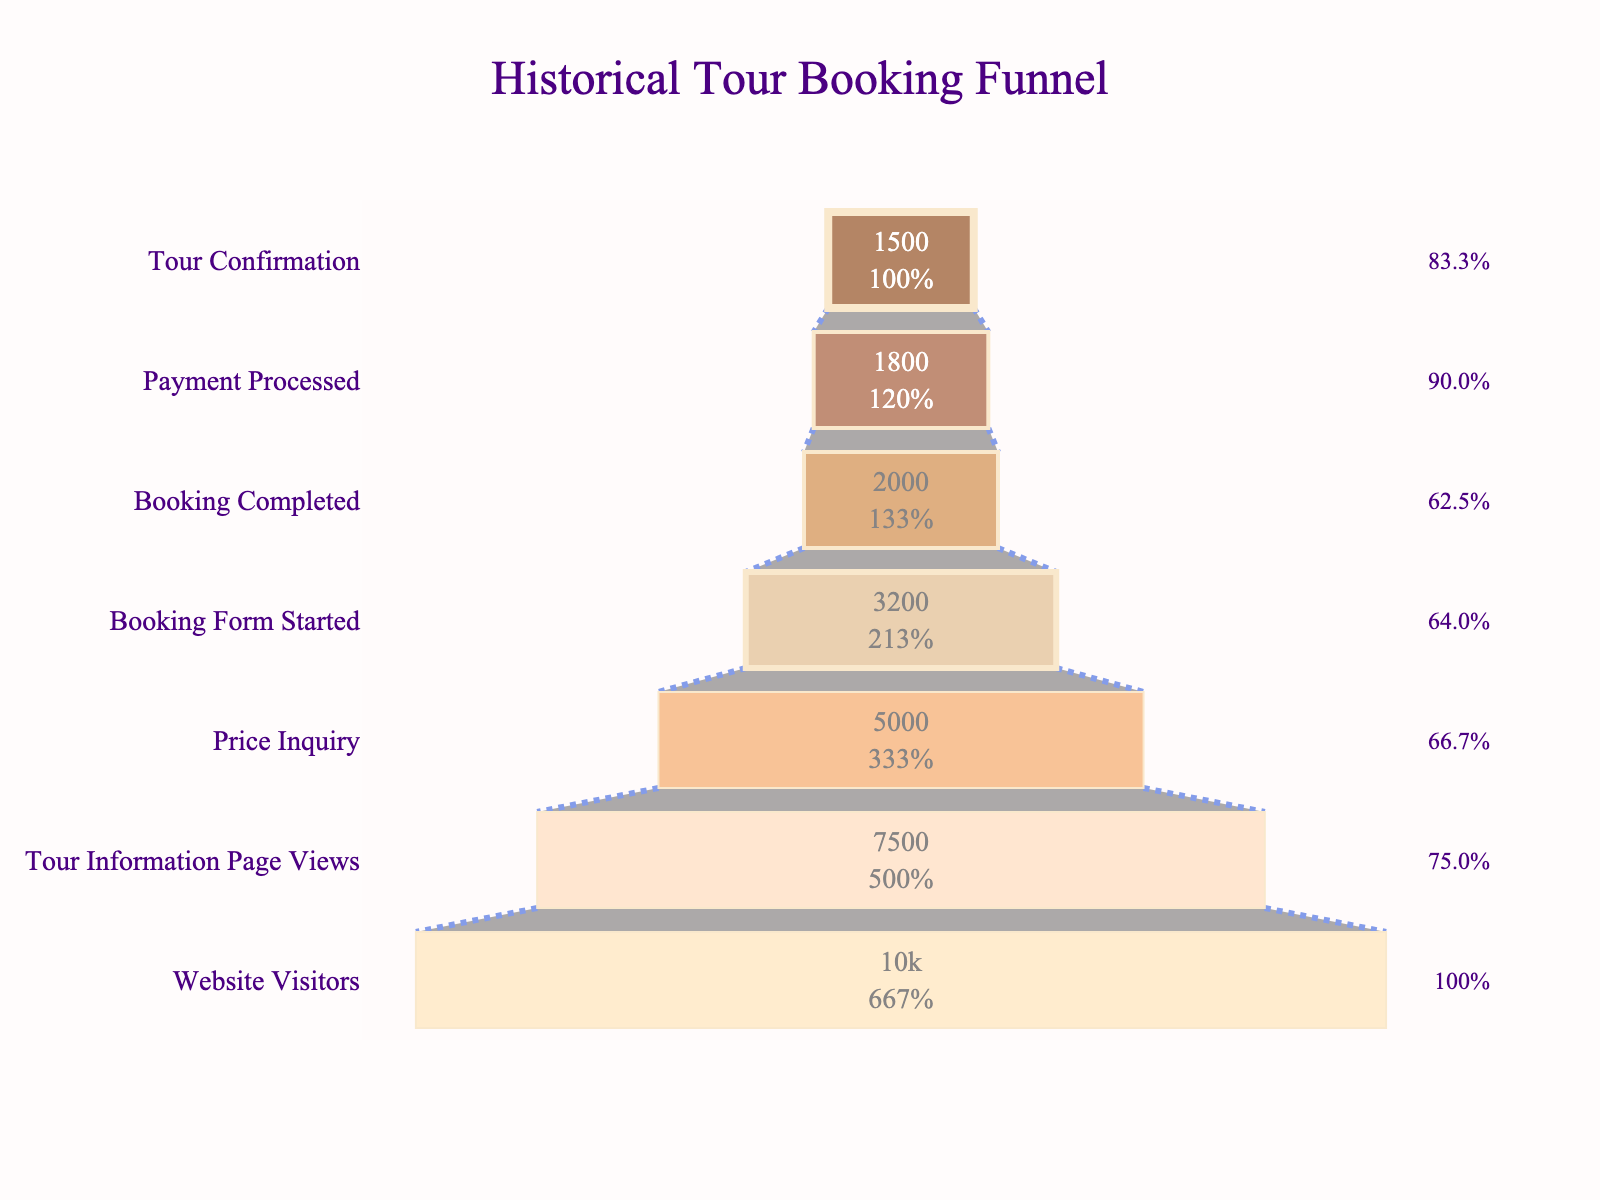how many visitors started the booking form? To find the number of visitors who started the booking form, look at the "Booking Form Started" stage in the funnel chart. The value associated with this stage is the number of visitors who began filling out the booking form.
Answer: 3200 what percentage of visitors from the Tour Information Page Views went on to complete the booking form? To calculate this percentage, divide the number of visitors who completed the booking form by the number who viewed the tour information page, then multiply by 100. Specifically, 3200 (Booking Form Started) divided by 7500 (Tour Information Page Views), then multiplied by 100.
Answer: 42.7% how many visitors converted from price inquiry to payment processed? Look at the values for "Payment Processed" and "Price Inquiry." Subtract the number of visitors at the "Payment Processed" stage from those at the "Price Inquiry" stage: 5000 (Price Inquiry) - 1800 (Payment Processed).
Answer: 3200 which stage sees the highest drop-off in visitors? To determine the highest drop-off, calculate the difference in visitors between each consecutive stage and find the maximum difference. The largest drop-off happens between "Booking Form Started" and "Booking Completed" stages.
Answer: Booking Form Started to Booking Completed what is the final conversion rate from website visitors to tour confirmation? To find the conversion rate, divide the number of visitors who reached "Tour Confirmation" by the number of "Website Visitors" and multiply by 100. Specifically, it's 1500 (Tour Confirmation) divided by 10000 (Website Visitors) times 100.
Answer: 15% what is the percentage drop-off between the Booking Completed and Payment Processed stages? To find this percentage, take the difference in visitors between the two stages and divide by the number of visitors at the "Booking Completed" stage, then multiply by 100: ((2000 - 1800) / 2000) * 100.
Answer: 10% how does the number of visitors at the Price Inquiry stage compare to those at the Booking Completed stage? Compare the values for "Price Inquiry" (5000) and "Booking Completed" (2000) directly to see that more visitors are at the "Price Inquiry" stage than at the "Booking Completed" stage.
Answer: More at Price Inquiry what is the percentage retention from the Booking Form Started stage to the Tour Confirmation stage? Divide the number of visitors at the "Tour Confirmation" stage by those at the "Booking Form Started" stage, then multiply by 100: (1500 / 3200) * 100.
Answer: 46.9% list the stages in descending order by the number of visitors. To list the stages in descending order by the number of visitors, order the stages from highest to lowest visitor counts: Website Visitors -> Tour Information Page Views -> Price Inquiry -> Booking Form Started -> Booking Completed -> Payment Processed -> Tour Confirmation.
Answer: Website Visitors, Tour Information Page Views, Price Inquiry, Booking Form Started, Booking Completed, Payment Processed, Tour Confirmation 